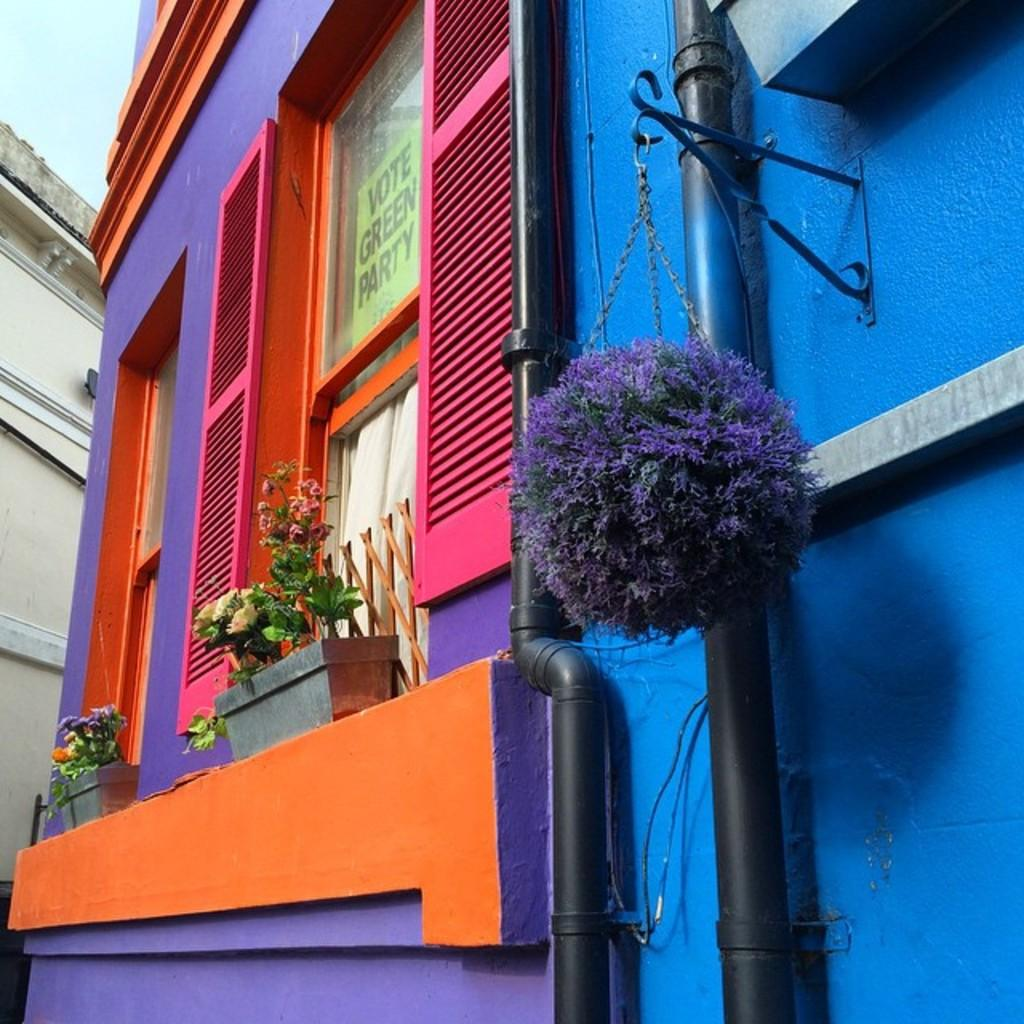What type of structures can be seen in the image? There are buildings in the image. What other objects are present in the image? There are flower pots and pipes attached to a blue wall in the image. Are there any openings in the buildings? Yes, there are windows in the image. What can be seen in the background of the image? The sky is visible in the image. What type of tank is visible in the image? There is no tank present in the image. How does the death of a character affect the story in the image? There is no story or character depicted in the image, so it is not possible to determine how the death of a character would affect the story. 